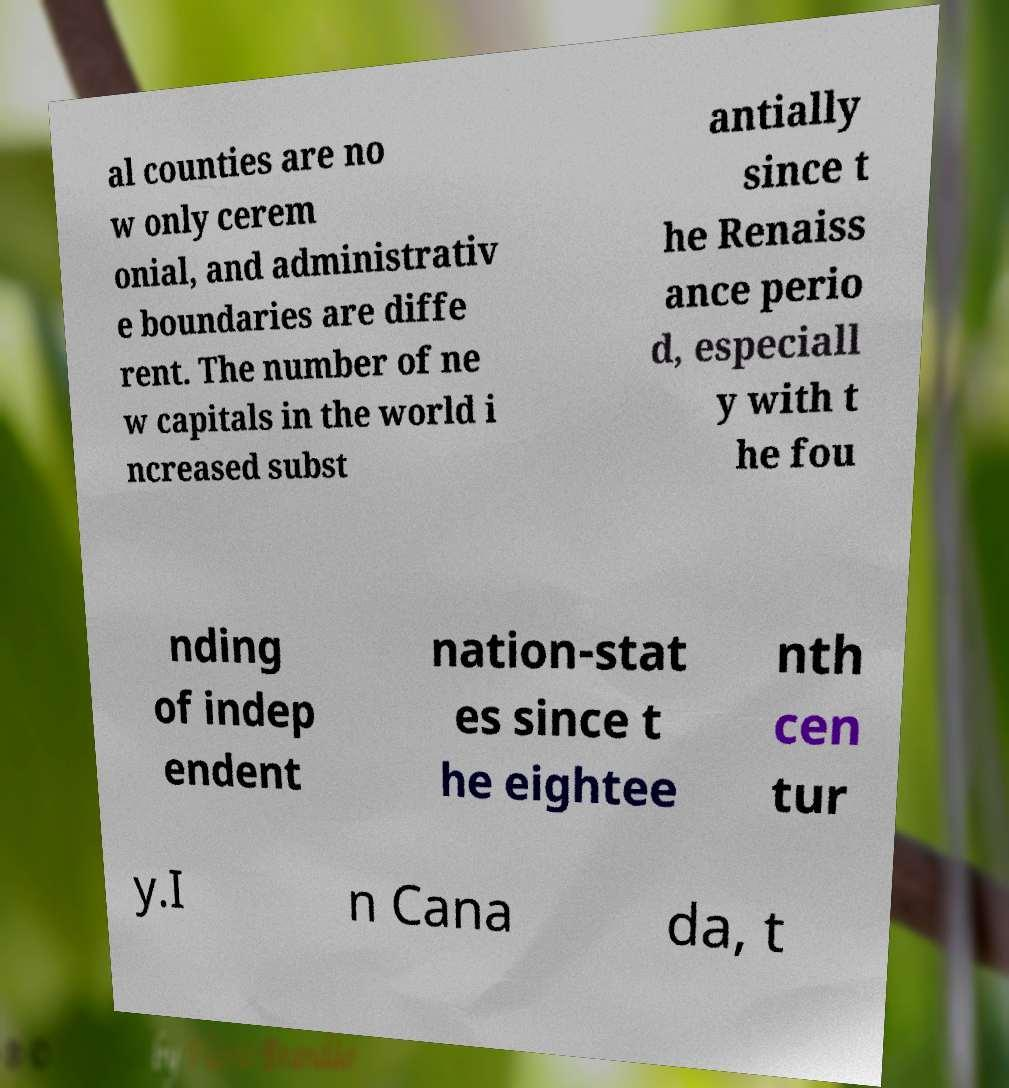Could you assist in decoding the text presented in this image and type it out clearly? al counties are no w only cerem onial, and administrativ e boundaries are diffe rent. The number of ne w capitals in the world i ncreased subst antially since t he Renaiss ance perio d, especiall y with t he fou nding of indep endent nation-stat es since t he eightee nth cen tur y.I n Cana da, t 